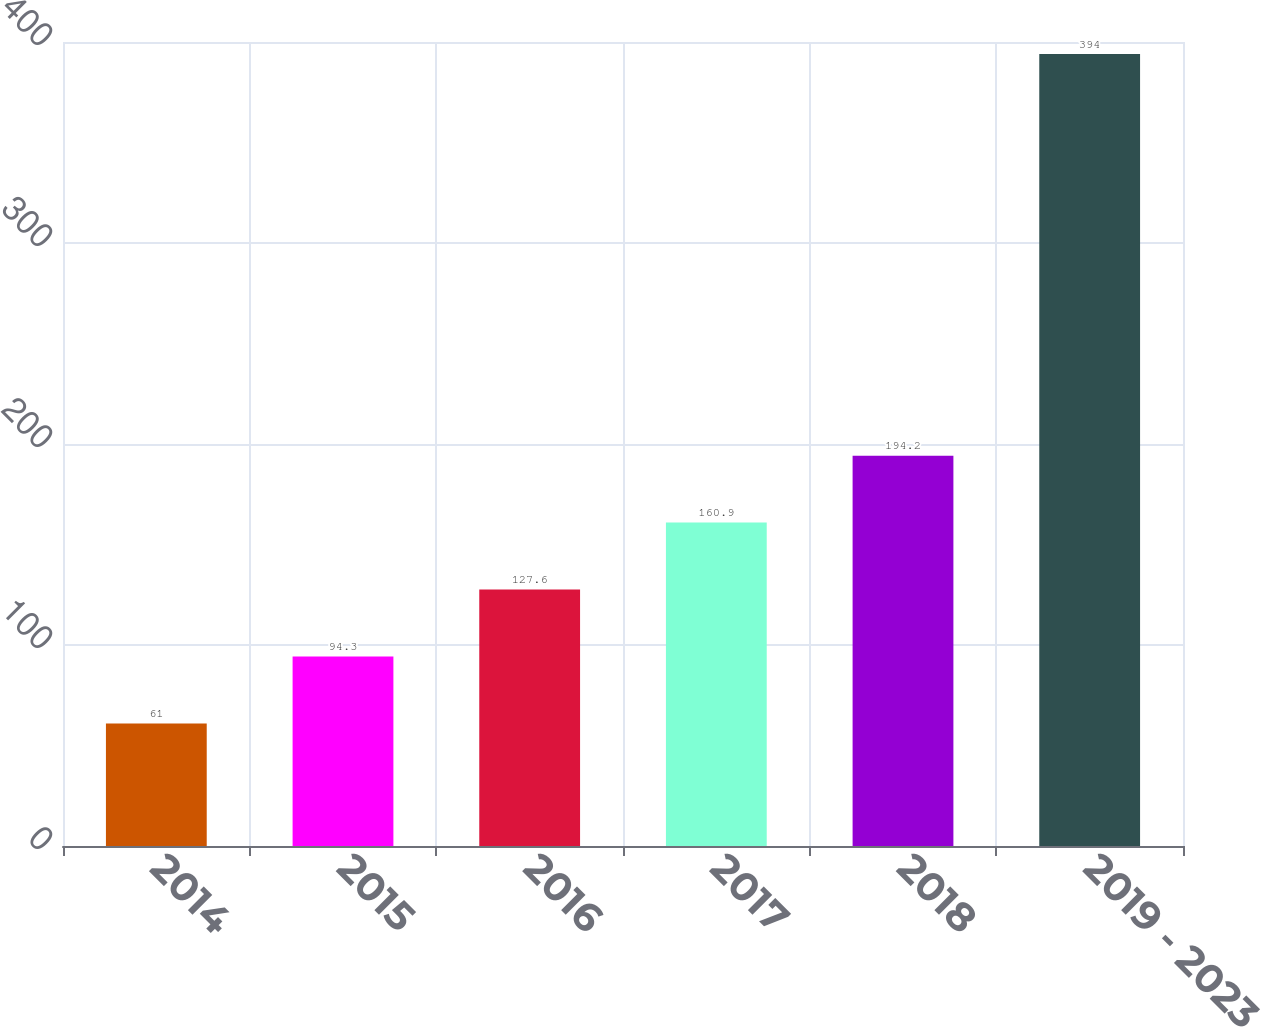Convert chart. <chart><loc_0><loc_0><loc_500><loc_500><bar_chart><fcel>2014<fcel>2015<fcel>2016<fcel>2017<fcel>2018<fcel>2019 - 2023<nl><fcel>61<fcel>94.3<fcel>127.6<fcel>160.9<fcel>194.2<fcel>394<nl></chart> 